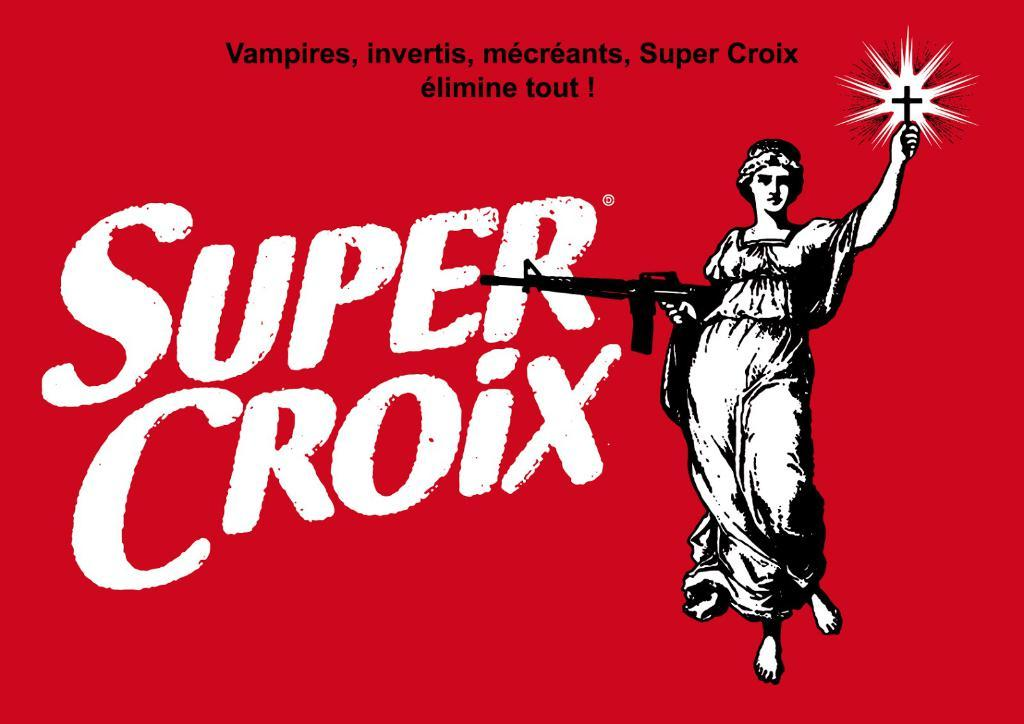<image>
Give a short and clear explanation of the subsequent image. an advertisement for something called the super croix 